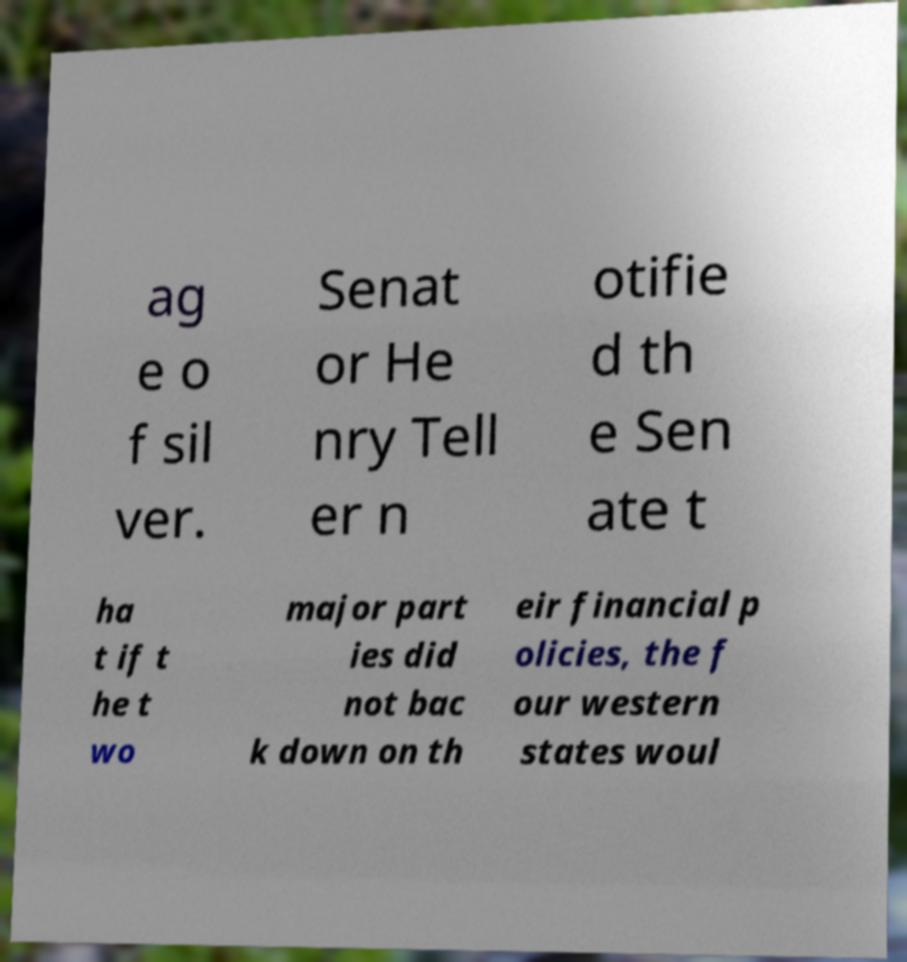For documentation purposes, I need the text within this image transcribed. Could you provide that? ag e o f sil ver. Senat or He nry Tell er n otifie d th e Sen ate t ha t if t he t wo major part ies did not bac k down on th eir financial p olicies, the f our western states woul 